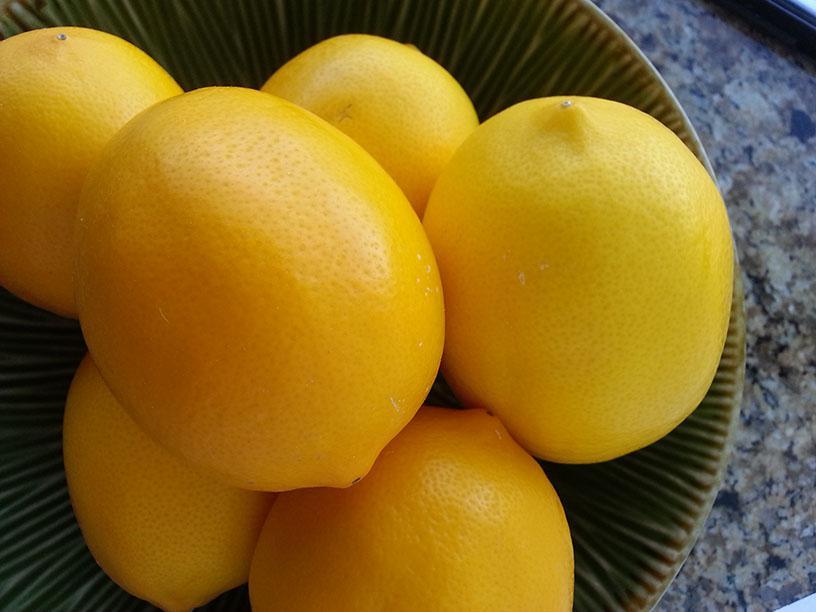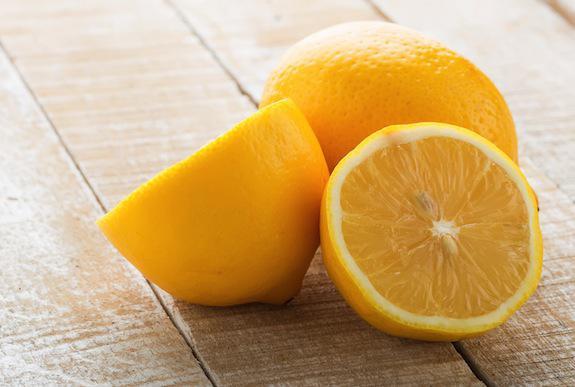The first image is the image on the left, the second image is the image on the right. Examine the images to the left and right. Is the description "There are at least 8 lemons." accurate? Answer yes or no. Yes. The first image is the image on the left, the second image is the image on the right. Assess this claim about the two images: "There are more than two whole lemons.". Correct or not? Answer yes or no. Yes. 